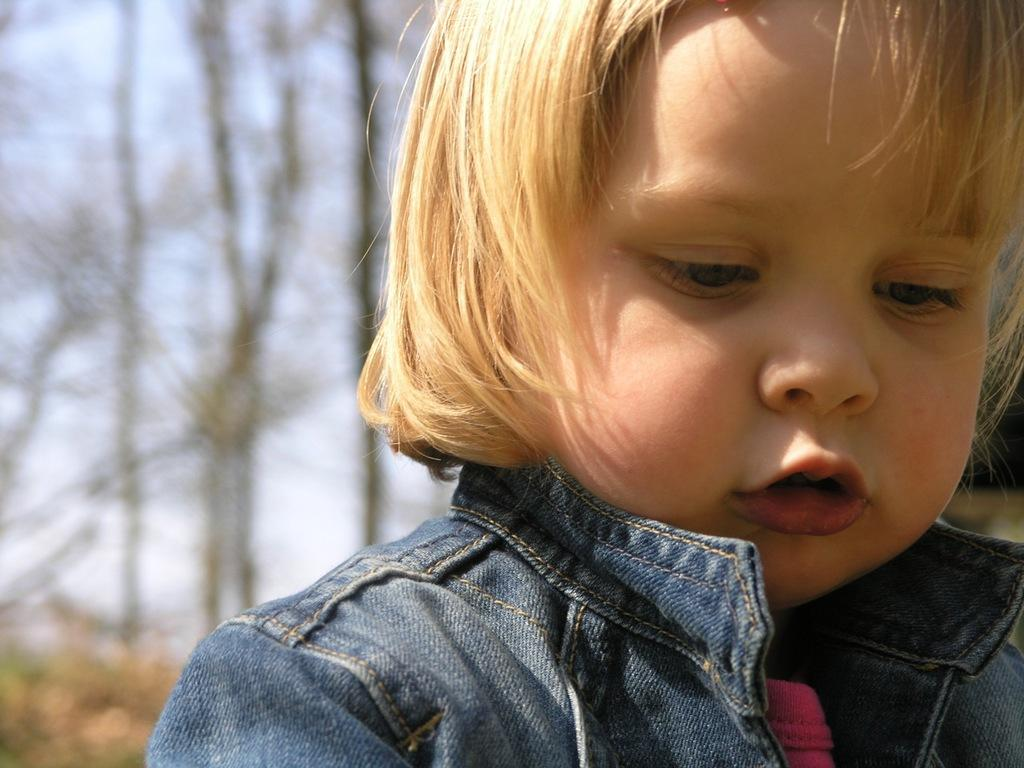Who is the main subject in the image? There is a small girl in the image. What is the girl wearing? The girl is wearing a jacket. What can be seen in the background of the image? There are trees in the background of the image. How many beans are visible on the girl's leg in the image? There are no beans visible on the girl's leg in the image. What type of underwear is the girl wearing in the image? The provided facts do not mention the girl's underwear, so it cannot be determined from the image. 